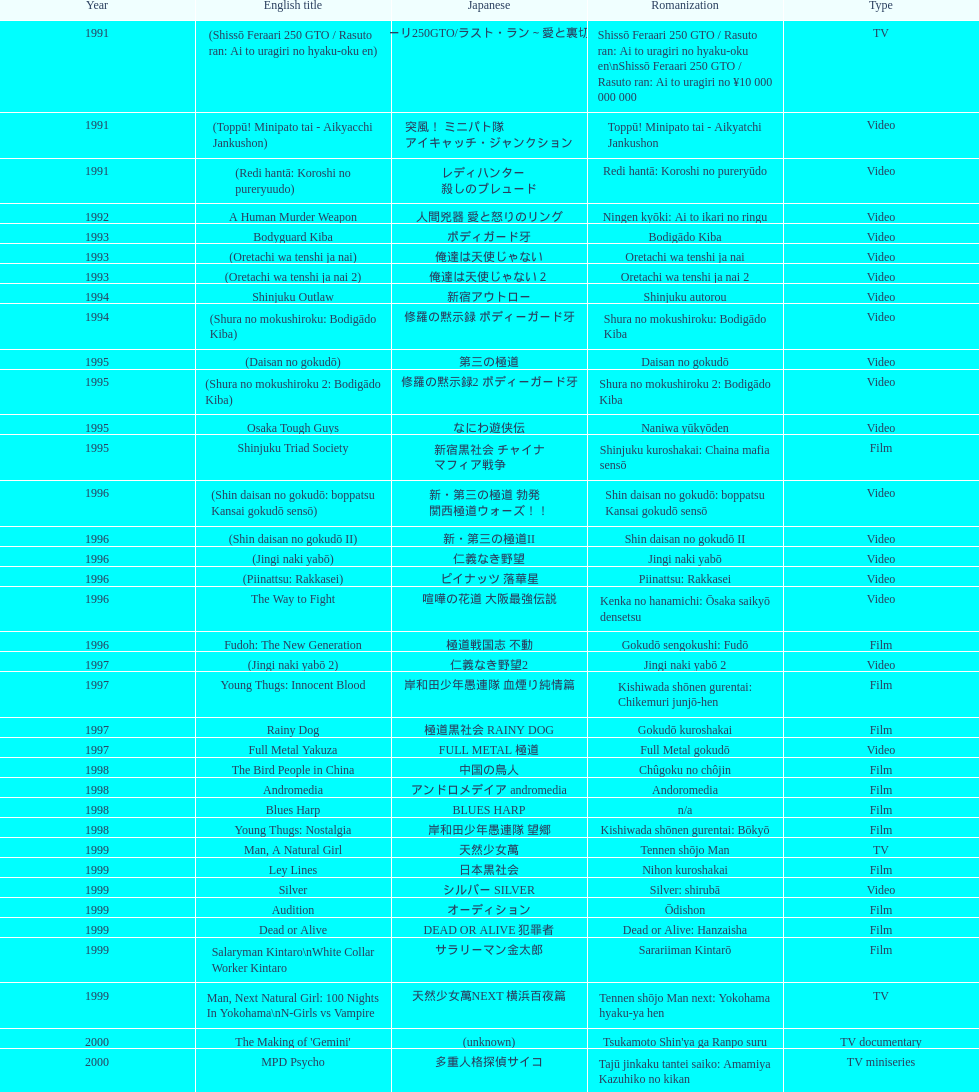Did television or video have more airtime? Video. 